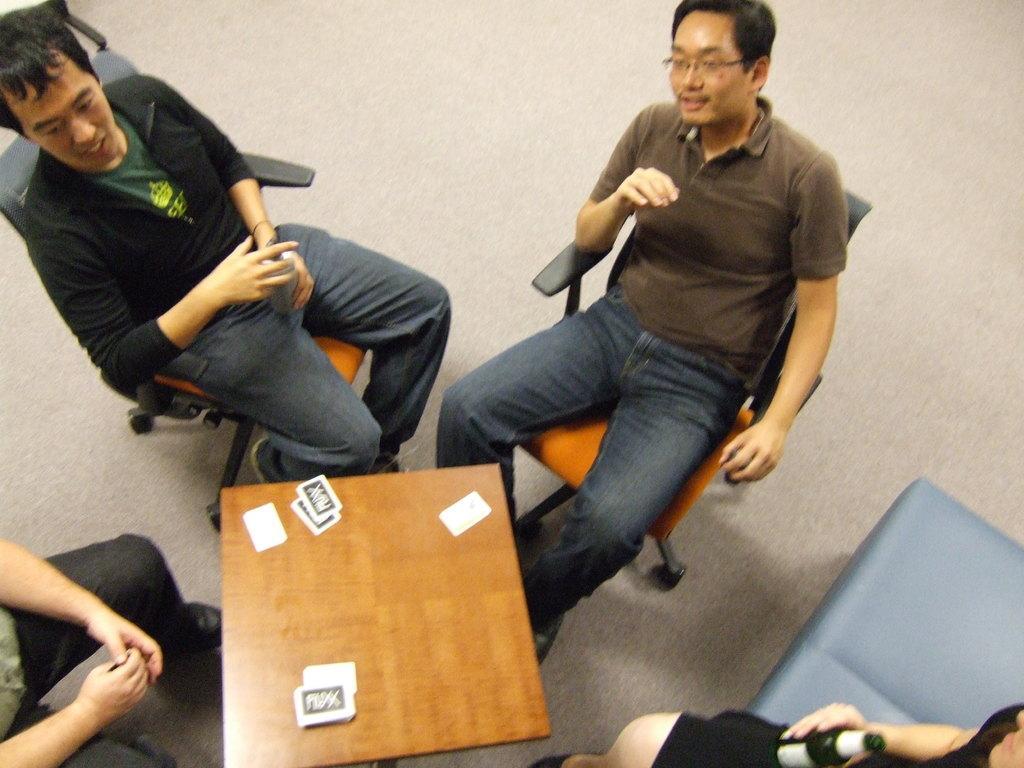How would you summarize this image in a sentence or two? In this image there are few people sitting on chair, in front of them there is a table, on the table there are some cards. 